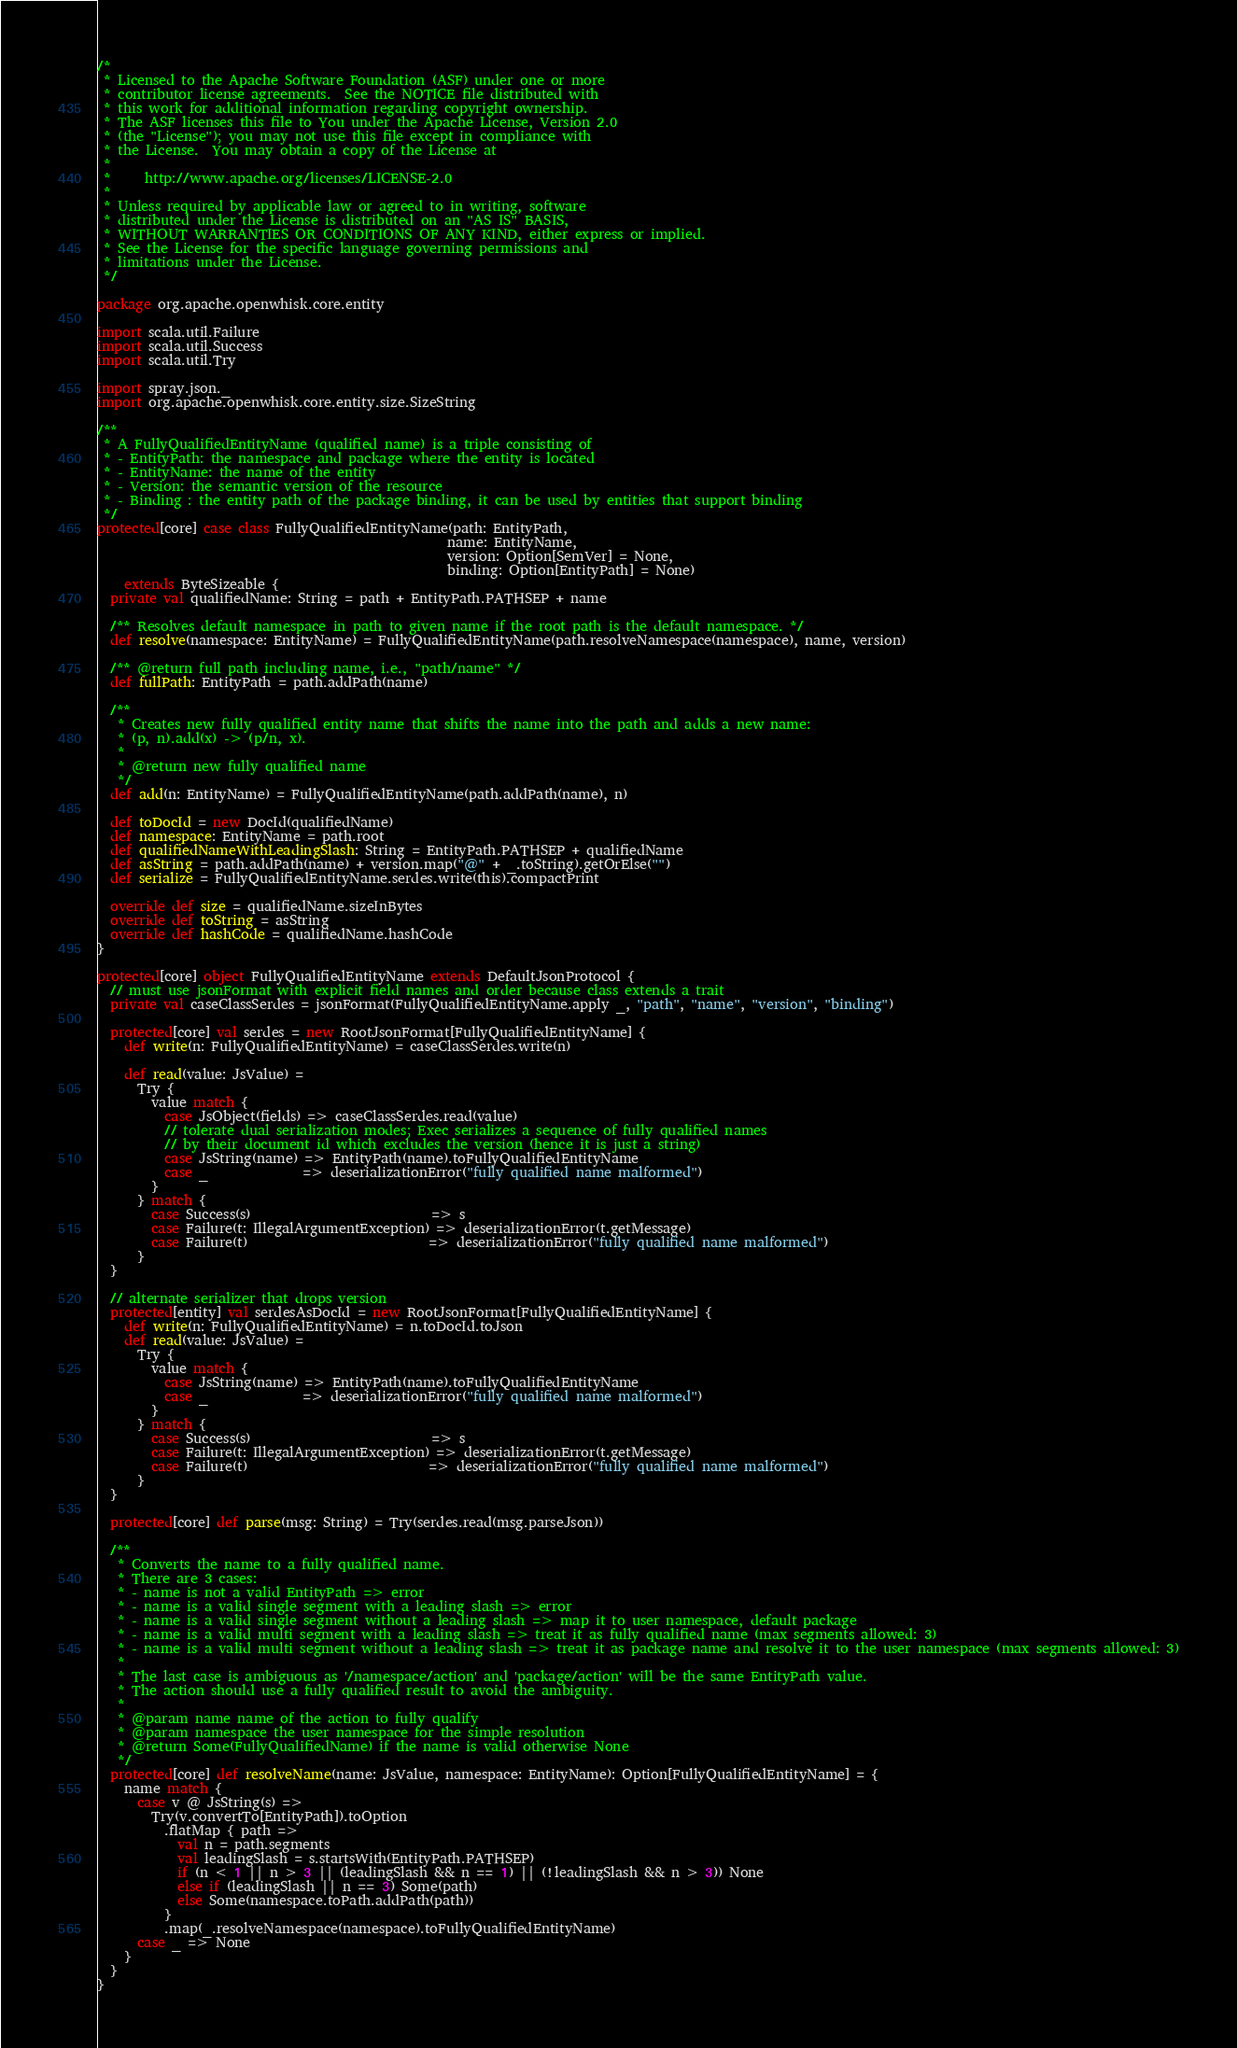Convert code to text. <code><loc_0><loc_0><loc_500><loc_500><_Scala_>/*
 * Licensed to the Apache Software Foundation (ASF) under one or more
 * contributor license agreements.  See the NOTICE file distributed with
 * this work for additional information regarding copyright ownership.
 * The ASF licenses this file to You under the Apache License, Version 2.0
 * (the "License"); you may not use this file except in compliance with
 * the License.  You may obtain a copy of the License at
 *
 *     http://www.apache.org/licenses/LICENSE-2.0
 *
 * Unless required by applicable law or agreed to in writing, software
 * distributed under the License is distributed on an "AS IS" BASIS,
 * WITHOUT WARRANTIES OR CONDITIONS OF ANY KIND, either express or implied.
 * See the License for the specific language governing permissions and
 * limitations under the License.
 */

package org.apache.openwhisk.core.entity

import scala.util.Failure
import scala.util.Success
import scala.util.Try

import spray.json._
import org.apache.openwhisk.core.entity.size.SizeString

/**
 * A FullyQualifiedEntityName (qualified name) is a triple consisting of
 * - EntityPath: the namespace and package where the entity is located
 * - EntityName: the name of the entity
 * - Version: the semantic version of the resource
 * - Binding : the entity path of the package binding, it can be used by entities that support binding
 */
protected[core] case class FullyQualifiedEntityName(path: EntityPath,
                                                    name: EntityName,
                                                    version: Option[SemVer] = None,
                                                    binding: Option[EntityPath] = None)
    extends ByteSizeable {
  private val qualifiedName: String = path + EntityPath.PATHSEP + name

  /** Resolves default namespace in path to given name if the root path is the default namespace. */
  def resolve(namespace: EntityName) = FullyQualifiedEntityName(path.resolveNamespace(namespace), name, version)

  /** @return full path including name, i.e., "path/name" */
  def fullPath: EntityPath = path.addPath(name)

  /**
   * Creates new fully qualified entity name that shifts the name into the path and adds a new name:
   * (p, n).add(x) -> (p/n, x).
   *
   * @return new fully qualified name
   */
  def add(n: EntityName) = FullyQualifiedEntityName(path.addPath(name), n)

  def toDocId = new DocId(qualifiedName)
  def namespace: EntityName = path.root
  def qualifiedNameWithLeadingSlash: String = EntityPath.PATHSEP + qualifiedName
  def asString = path.addPath(name) + version.map("@" + _.toString).getOrElse("")
  def serialize = FullyQualifiedEntityName.serdes.write(this).compactPrint

  override def size = qualifiedName.sizeInBytes
  override def toString = asString
  override def hashCode = qualifiedName.hashCode
}

protected[core] object FullyQualifiedEntityName extends DefaultJsonProtocol {
  // must use jsonFormat with explicit field names and order because class extends a trait
  private val caseClassSerdes = jsonFormat(FullyQualifiedEntityName.apply _, "path", "name", "version", "binding")

  protected[core] val serdes = new RootJsonFormat[FullyQualifiedEntityName] {
    def write(n: FullyQualifiedEntityName) = caseClassSerdes.write(n)

    def read(value: JsValue) =
      Try {
        value match {
          case JsObject(fields) => caseClassSerdes.read(value)
          // tolerate dual serialization modes; Exec serializes a sequence of fully qualified names
          // by their document id which excludes the version (hence it is just a string)
          case JsString(name) => EntityPath(name).toFullyQualifiedEntityName
          case _              => deserializationError("fully qualified name malformed")
        }
      } match {
        case Success(s)                           => s
        case Failure(t: IllegalArgumentException) => deserializationError(t.getMessage)
        case Failure(t)                           => deserializationError("fully qualified name malformed")
      }
  }

  // alternate serializer that drops version
  protected[entity] val serdesAsDocId = new RootJsonFormat[FullyQualifiedEntityName] {
    def write(n: FullyQualifiedEntityName) = n.toDocId.toJson
    def read(value: JsValue) =
      Try {
        value match {
          case JsString(name) => EntityPath(name).toFullyQualifiedEntityName
          case _              => deserializationError("fully qualified name malformed")
        }
      } match {
        case Success(s)                           => s
        case Failure(t: IllegalArgumentException) => deserializationError(t.getMessage)
        case Failure(t)                           => deserializationError("fully qualified name malformed")
      }
  }

  protected[core] def parse(msg: String) = Try(serdes.read(msg.parseJson))

  /**
   * Converts the name to a fully qualified name.
   * There are 3 cases:
   * - name is not a valid EntityPath => error
   * - name is a valid single segment with a leading slash => error
   * - name is a valid single segment without a leading slash => map it to user namespace, default package
   * - name is a valid multi segment with a leading slash => treat it as fully qualified name (max segments allowed: 3)
   * - name is a valid multi segment without a leading slash => treat it as package name and resolve it to the user namespace (max segments allowed: 3)
   *
   * The last case is ambiguous as '/namespace/action' and 'package/action' will be the same EntityPath value.
   * The action should use a fully qualified result to avoid the ambiguity.
   *
   * @param name name of the action to fully qualify
   * @param namespace the user namespace for the simple resolution
   * @return Some(FullyQualifiedName) if the name is valid otherwise None
   */
  protected[core] def resolveName(name: JsValue, namespace: EntityName): Option[FullyQualifiedEntityName] = {
    name match {
      case v @ JsString(s) =>
        Try(v.convertTo[EntityPath]).toOption
          .flatMap { path =>
            val n = path.segments
            val leadingSlash = s.startsWith(EntityPath.PATHSEP)
            if (n < 1 || n > 3 || (leadingSlash && n == 1) || (!leadingSlash && n > 3)) None
            else if (leadingSlash || n == 3) Some(path)
            else Some(namespace.toPath.addPath(path))
          }
          .map(_.resolveNamespace(namespace).toFullyQualifiedEntityName)
      case _ => None
    }
  }
}
</code> 